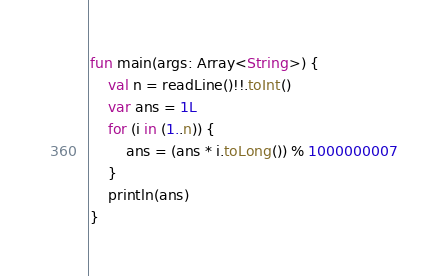Convert code to text. <code><loc_0><loc_0><loc_500><loc_500><_Kotlin_>fun main(args: Array<String>) {
    val n = readLine()!!.toInt()
    var ans = 1L
    for (i in (1..n)) {
        ans = (ans * i.toLong()) % 1000000007
    }
    println(ans)
}</code> 